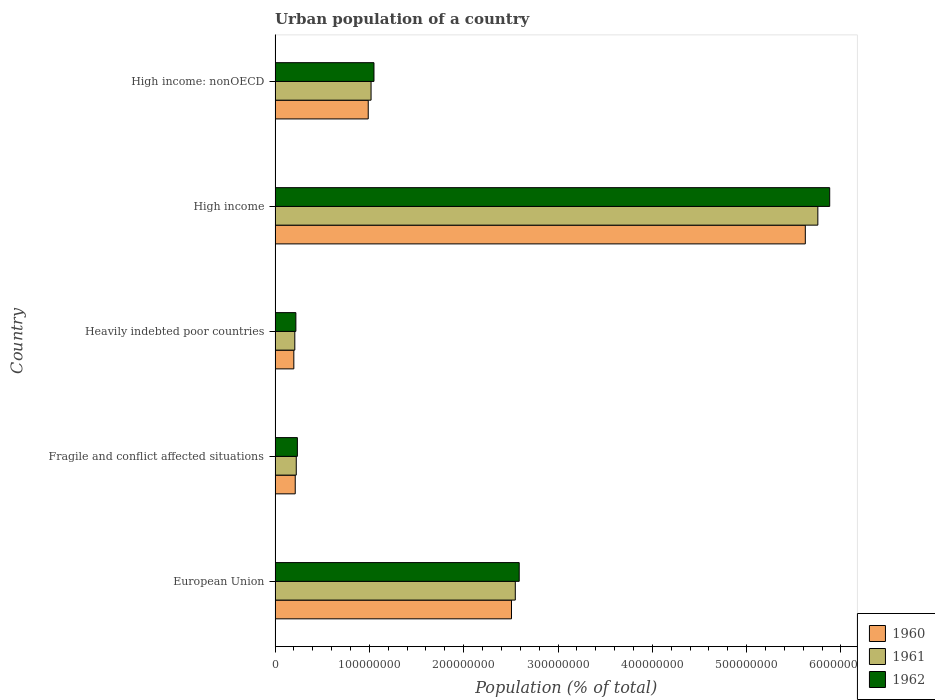How many different coloured bars are there?
Keep it short and to the point. 3. How many groups of bars are there?
Offer a very short reply. 5. How many bars are there on the 2nd tick from the bottom?
Keep it short and to the point. 3. What is the label of the 4th group of bars from the top?
Offer a very short reply. Fragile and conflict affected situations. What is the urban population in 1962 in Heavily indebted poor countries?
Ensure brevity in your answer.  2.20e+07. Across all countries, what is the maximum urban population in 1962?
Make the answer very short. 5.88e+08. Across all countries, what is the minimum urban population in 1960?
Keep it short and to the point. 1.99e+07. In which country was the urban population in 1960 minimum?
Provide a succinct answer. Heavily indebted poor countries. What is the total urban population in 1962 in the graph?
Give a very brief answer. 9.97e+08. What is the difference between the urban population in 1960 in European Union and that in Heavily indebted poor countries?
Your answer should be compact. 2.31e+08. What is the difference between the urban population in 1961 in High income and the urban population in 1962 in European Union?
Offer a very short reply. 3.17e+08. What is the average urban population in 1961 per country?
Your response must be concise. 1.95e+08. What is the difference between the urban population in 1962 and urban population in 1960 in High income: nonOECD?
Give a very brief answer. 6.07e+06. What is the ratio of the urban population in 1960 in High income to that in High income: nonOECD?
Give a very brief answer. 5.69. Is the urban population in 1961 in European Union less than that in Fragile and conflict affected situations?
Offer a terse response. No. What is the difference between the highest and the second highest urban population in 1960?
Provide a succinct answer. 3.12e+08. What is the difference between the highest and the lowest urban population in 1960?
Your answer should be compact. 5.42e+08. What does the 2nd bar from the top in Fragile and conflict affected situations represents?
Offer a very short reply. 1961. Are all the bars in the graph horizontal?
Ensure brevity in your answer.  Yes. Are the values on the major ticks of X-axis written in scientific E-notation?
Provide a succinct answer. No. Does the graph contain any zero values?
Offer a terse response. No. Does the graph contain grids?
Offer a terse response. No. How are the legend labels stacked?
Offer a very short reply. Vertical. What is the title of the graph?
Give a very brief answer. Urban population of a country. What is the label or title of the X-axis?
Your answer should be very brief. Population (% of total). What is the label or title of the Y-axis?
Make the answer very short. Country. What is the Population (% of total) of 1960 in European Union?
Keep it short and to the point. 2.51e+08. What is the Population (% of total) in 1961 in European Union?
Your response must be concise. 2.55e+08. What is the Population (% of total) of 1962 in European Union?
Give a very brief answer. 2.59e+08. What is the Population (% of total) of 1960 in Fragile and conflict affected situations?
Provide a short and direct response. 2.14e+07. What is the Population (% of total) of 1961 in Fragile and conflict affected situations?
Keep it short and to the point. 2.25e+07. What is the Population (% of total) of 1962 in Fragile and conflict affected situations?
Your answer should be compact. 2.36e+07. What is the Population (% of total) in 1960 in Heavily indebted poor countries?
Ensure brevity in your answer.  1.99e+07. What is the Population (% of total) of 1961 in Heavily indebted poor countries?
Offer a very short reply. 2.09e+07. What is the Population (% of total) of 1962 in Heavily indebted poor countries?
Ensure brevity in your answer.  2.20e+07. What is the Population (% of total) in 1960 in High income?
Provide a short and direct response. 5.62e+08. What is the Population (% of total) in 1961 in High income?
Ensure brevity in your answer.  5.76e+08. What is the Population (% of total) in 1962 in High income?
Offer a terse response. 5.88e+08. What is the Population (% of total) in 1960 in High income: nonOECD?
Provide a short and direct response. 9.88e+07. What is the Population (% of total) in 1961 in High income: nonOECD?
Keep it short and to the point. 1.02e+08. What is the Population (% of total) of 1962 in High income: nonOECD?
Offer a very short reply. 1.05e+08. Across all countries, what is the maximum Population (% of total) of 1960?
Your answer should be compact. 5.62e+08. Across all countries, what is the maximum Population (% of total) of 1961?
Ensure brevity in your answer.  5.76e+08. Across all countries, what is the maximum Population (% of total) in 1962?
Keep it short and to the point. 5.88e+08. Across all countries, what is the minimum Population (% of total) in 1960?
Keep it short and to the point. 1.99e+07. Across all countries, what is the minimum Population (% of total) of 1961?
Offer a terse response. 2.09e+07. Across all countries, what is the minimum Population (% of total) in 1962?
Make the answer very short. 2.20e+07. What is the total Population (% of total) of 1960 in the graph?
Make the answer very short. 9.53e+08. What is the total Population (% of total) in 1961 in the graph?
Offer a very short reply. 9.75e+08. What is the total Population (% of total) in 1962 in the graph?
Ensure brevity in your answer.  9.97e+08. What is the difference between the Population (% of total) in 1960 in European Union and that in Fragile and conflict affected situations?
Give a very brief answer. 2.29e+08. What is the difference between the Population (% of total) in 1961 in European Union and that in Fragile and conflict affected situations?
Give a very brief answer. 2.32e+08. What is the difference between the Population (% of total) of 1962 in European Union and that in Fragile and conflict affected situations?
Make the answer very short. 2.35e+08. What is the difference between the Population (% of total) of 1960 in European Union and that in Heavily indebted poor countries?
Your response must be concise. 2.31e+08. What is the difference between the Population (% of total) of 1961 in European Union and that in Heavily indebted poor countries?
Ensure brevity in your answer.  2.34e+08. What is the difference between the Population (% of total) in 1962 in European Union and that in Heavily indebted poor countries?
Provide a short and direct response. 2.37e+08. What is the difference between the Population (% of total) of 1960 in European Union and that in High income?
Provide a succinct answer. -3.12e+08. What is the difference between the Population (% of total) of 1961 in European Union and that in High income?
Keep it short and to the point. -3.21e+08. What is the difference between the Population (% of total) of 1962 in European Union and that in High income?
Give a very brief answer. -3.29e+08. What is the difference between the Population (% of total) in 1960 in European Union and that in High income: nonOECD?
Give a very brief answer. 1.52e+08. What is the difference between the Population (% of total) of 1961 in European Union and that in High income: nonOECD?
Keep it short and to the point. 1.53e+08. What is the difference between the Population (% of total) of 1962 in European Union and that in High income: nonOECD?
Ensure brevity in your answer.  1.54e+08. What is the difference between the Population (% of total) in 1960 in Fragile and conflict affected situations and that in Heavily indebted poor countries?
Ensure brevity in your answer.  1.48e+06. What is the difference between the Population (% of total) of 1961 in Fragile and conflict affected situations and that in Heavily indebted poor countries?
Make the answer very short. 1.53e+06. What is the difference between the Population (% of total) of 1962 in Fragile and conflict affected situations and that in Heavily indebted poor countries?
Keep it short and to the point. 1.59e+06. What is the difference between the Population (% of total) of 1960 in Fragile and conflict affected situations and that in High income?
Make the answer very short. -5.41e+08. What is the difference between the Population (% of total) of 1961 in Fragile and conflict affected situations and that in High income?
Offer a very short reply. -5.53e+08. What is the difference between the Population (% of total) in 1962 in Fragile and conflict affected situations and that in High income?
Provide a short and direct response. -5.64e+08. What is the difference between the Population (% of total) of 1960 in Fragile and conflict affected situations and that in High income: nonOECD?
Provide a succinct answer. -7.74e+07. What is the difference between the Population (% of total) in 1961 in Fragile and conflict affected situations and that in High income: nonOECD?
Keep it short and to the point. -7.93e+07. What is the difference between the Population (% of total) in 1962 in Fragile and conflict affected situations and that in High income: nonOECD?
Ensure brevity in your answer.  -8.12e+07. What is the difference between the Population (% of total) in 1960 in Heavily indebted poor countries and that in High income?
Your response must be concise. -5.42e+08. What is the difference between the Population (% of total) of 1961 in Heavily indebted poor countries and that in High income?
Make the answer very short. -5.55e+08. What is the difference between the Population (% of total) in 1962 in Heavily indebted poor countries and that in High income?
Offer a terse response. -5.66e+08. What is the difference between the Population (% of total) in 1960 in Heavily indebted poor countries and that in High income: nonOECD?
Make the answer very short. -7.89e+07. What is the difference between the Population (% of total) in 1961 in Heavily indebted poor countries and that in High income: nonOECD?
Provide a short and direct response. -8.08e+07. What is the difference between the Population (% of total) of 1962 in Heavily indebted poor countries and that in High income: nonOECD?
Your answer should be compact. -8.28e+07. What is the difference between the Population (% of total) in 1960 in High income and that in High income: nonOECD?
Offer a terse response. 4.63e+08. What is the difference between the Population (% of total) in 1961 in High income and that in High income: nonOECD?
Make the answer very short. 4.74e+08. What is the difference between the Population (% of total) in 1962 in High income and that in High income: nonOECD?
Your answer should be very brief. 4.83e+08. What is the difference between the Population (% of total) of 1960 in European Union and the Population (% of total) of 1961 in Fragile and conflict affected situations?
Make the answer very short. 2.28e+08. What is the difference between the Population (% of total) in 1960 in European Union and the Population (% of total) in 1962 in Fragile and conflict affected situations?
Your answer should be very brief. 2.27e+08. What is the difference between the Population (% of total) in 1961 in European Union and the Population (% of total) in 1962 in Fragile and conflict affected situations?
Offer a very short reply. 2.31e+08. What is the difference between the Population (% of total) of 1960 in European Union and the Population (% of total) of 1961 in Heavily indebted poor countries?
Provide a short and direct response. 2.30e+08. What is the difference between the Population (% of total) in 1960 in European Union and the Population (% of total) in 1962 in Heavily indebted poor countries?
Your answer should be compact. 2.29e+08. What is the difference between the Population (% of total) in 1961 in European Union and the Population (% of total) in 1962 in Heavily indebted poor countries?
Give a very brief answer. 2.33e+08. What is the difference between the Population (% of total) of 1960 in European Union and the Population (% of total) of 1961 in High income?
Your response must be concise. -3.25e+08. What is the difference between the Population (% of total) of 1960 in European Union and the Population (% of total) of 1962 in High income?
Your answer should be very brief. -3.37e+08. What is the difference between the Population (% of total) in 1961 in European Union and the Population (% of total) in 1962 in High income?
Your response must be concise. -3.33e+08. What is the difference between the Population (% of total) of 1960 in European Union and the Population (% of total) of 1961 in High income: nonOECD?
Offer a terse response. 1.49e+08. What is the difference between the Population (% of total) of 1960 in European Union and the Population (% of total) of 1962 in High income: nonOECD?
Your answer should be very brief. 1.46e+08. What is the difference between the Population (% of total) in 1961 in European Union and the Population (% of total) in 1962 in High income: nonOECD?
Your response must be concise. 1.50e+08. What is the difference between the Population (% of total) in 1960 in Fragile and conflict affected situations and the Population (% of total) in 1961 in Heavily indebted poor countries?
Make the answer very short. 4.34e+05. What is the difference between the Population (% of total) in 1960 in Fragile and conflict affected situations and the Population (% of total) in 1962 in Heavily indebted poor countries?
Make the answer very short. -6.80e+05. What is the difference between the Population (% of total) in 1961 in Fragile and conflict affected situations and the Population (% of total) in 1962 in Heavily indebted poor countries?
Give a very brief answer. 4.21e+05. What is the difference between the Population (% of total) in 1960 in Fragile and conflict affected situations and the Population (% of total) in 1961 in High income?
Your answer should be very brief. -5.54e+08. What is the difference between the Population (% of total) in 1960 in Fragile and conflict affected situations and the Population (% of total) in 1962 in High income?
Provide a short and direct response. -5.67e+08. What is the difference between the Population (% of total) of 1961 in Fragile and conflict affected situations and the Population (% of total) of 1962 in High income?
Offer a very short reply. -5.66e+08. What is the difference between the Population (% of total) of 1960 in Fragile and conflict affected situations and the Population (% of total) of 1961 in High income: nonOECD?
Your answer should be very brief. -8.04e+07. What is the difference between the Population (% of total) of 1960 in Fragile and conflict affected situations and the Population (% of total) of 1962 in High income: nonOECD?
Make the answer very short. -8.35e+07. What is the difference between the Population (% of total) in 1961 in Fragile and conflict affected situations and the Population (% of total) in 1962 in High income: nonOECD?
Give a very brief answer. -8.24e+07. What is the difference between the Population (% of total) in 1960 in Heavily indebted poor countries and the Population (% of total) in 1961 in High income?
Offer a very short reply. -5.56e+08. What is the difference between the Population (% of total) of 1960 in Heavily indebted poor countries and the Population (% of total) of 1962 in High income?
Keep it short and to the point. -5.68e+08. What is the difference between the Population (% of total) in 1961 in Heavily indebted poor countries and the Population (% of total) in 1962 in High income?
Give a very brief answer. -5.67e+08. What is the difference between the Population (% of total) in 1960 in Heavily indebted poor countries and the Population (% of total) in 1961 in High income: nonOECD?
Keep it short and to the point. -8.19e+07. What is the difference between the Population (% of total) in 1960 in Heavily indebted poor countries and the Population (% of total) in 1962 in High income: nonOECD?
Provide a succinct answer. -8.50e+07. What is the difference between the Population (% of total) of 1961 in Heavily indebted poor countries and the Population (% of total) of 1962 in High income: nonOECD?
Ensure brevity in your answer.  -8.39e+07. What is the difference between the Population (% of total) in 1960 in High income and the Population (% of total) in 1961 in High income: nonOECD?
Offer a very short reply. 4.60e+08. What is the difference between the Population (% of total) in 1960 in High income and the Population (% of total) in 1962 in High income: nonOECD?
Offer a very short reply. 4.57e+08. What is the difference between the Population (% of total) of 1961 in High income and the Population (% of total) of 1962 in High income: nonOECD?
Your answer should be very brief. 4.71e+08. What is the average Population (% of total) of 1960 per country?
Your answer should be very brief. 1.91e+08. What is the average Population (% of total) of 1961 per country?
Your answer should be compact. 1.95e+08. What is the average Population (% of total) in 1962 per country?
Keep it short and to the point. 1.99e+08. What is the difference between the Population (% of total) of 1960 and Population (% of total) of 1961 in European Union?
Make the answer very short. -4.05e+06. What is the difference between the Population (% of total) of 1960 and Population (% of total) of 1962 in European Union?
Offer a very short reply. -8.20e+06. What is the difference between the Population (% of total) in 1961 and Population (% of total) in 1962 in European Union?
Your answer should be compact. -4.14e+06. What is the difference between the Population (% of total) in 1960 and Population (% of total) in 1961 in Fragile and conflict affected situations?
Provide a succinct answer. -1.10e+06. What is the difference between the Population (% of total) of 1960 and Population (% of total) of 1962 in Fragile and conflict affected situations?
Your answer should be very brief. -2.27e+06. What is the difference between the Population (% of total) of 1961 and Population (% of total) of 1962 in Fragile and conflict affected situations?
Provide a short and direct response. -1.17e+06. What is the difference between the Population (% of total) in 1960 and Population (% of total) in 1961 in Heavily indebted poor countries?
Keep it short and to the point. -1.05e+06. What is the difference between the Population (% of total) in 1960 and Population (% of total) in 1962 in Heavily indebted poor countries?
Make the answer very short. -2.16e+06. What is the difference between the Population (% of total) of 1961 and Population (% of total) of 1962 in Heavily indebted poor countries?
Provide a short and direct response. -1.11e+06. What is the difference between the Population (% of total) of 1960 and Population (% of total) of 1961 in High income?
Provide a succinct answer. -1.33e+07. What is the difference between the Population (% of total) in 1960 and Population (% of total) in 1962 in High income?
Offer a very short reply. -2.59e+07. What is the difference between the Population (% of total) of 1961 and Population (% of total) of 1962 in High income?
Ensure brevity in your answer.  -1.26e+07. What is the difference between the Population (% of total) in 1960 and Population (% of total) in 1961 in High income: nonOECD?
Your answer should be compact. -2.99e+06. What is the difference between the Population (% of total) in 1960 and Population (% of total) in 1962 in High income: nonOECD?
Provide a succinct answer. -6.07e+06. What is the difference between the Population (% of total) in 1961 and Population (% of total) in 1962 in High income: nonOECD?
Provide a succinct answer. -3.08e+06. What is the ratio of the Population (% of total) of 1960 in European Union to that in Fragile and conflict affected situations?
Give a very brief answer. 11.73. What is the ratio of the Population (% of total) in 1961 in European Union to that in Fragile and conflict affected situations?
Give a very brief answer. 11.34. What is the ratio of the Population (% of total) of 1962 in European Union to that in Fragile and conflict affected situations?
Provide a short and direct response. 10.95. What is the ratio of the Population (% of total) in 1960 in European Union to that in Heavily indebted poor countries?
Your answer should be very brief. 12.61. What is the ratio of the Population (% of total) of 1961 in European Union to that in Heavily indebted poor countries?
Ensure brevity in your answer.  12.17. What is the ratio of the Population (% of total) in 1962 in European Union to that in Heavily indebted poor countries?
Provide a succinct answer. 11.74. What is the ratio of the Population (% of total) of 1960 in European Union to that in High income?
Provide a succinct answer. 0.45. What is the ratio of the Population (% of total) in 1961 in European Union to that in High income?
Keep it short and to the point. 0.44. What is the ratio of the Population (% of total) of 1962 in European Union to that in High income?
Ensure brevity in your answer.  0.44. What is the ratio of the Population (% of total) in 1960 in European Union to that in High income: nonOECD?
Offer a very short reply. 2.54. What is the ratio of the Population (% of total) in 1961 in European Union to that in High income: nonOECD?
Make the answer very short. 2.5. What is the ratio of the Population (% of total) in 1962 in European Union to that in High income: nonOECD?
Provide a short and direct response. 2.47. What is the ratio of the Population (% of total) of 1960 in Fragile and conflict affected situations to that in Heavily indebted poor countries?
Make the answer very short. 1.07. What is the ratio of the Population (% of total) of 1961 in Fragile and conflict affected situations to that in Heavily indebted poor countries?
Offer a terse response. 1.07. What is the ratio of the Population (% of total) in 1962 in Fragile and conflict affected situations to that in Heavily indebted poor countries?
Offer a terse response. 1.07. What is the ratio of the Population (% of total) of 1960 in Fragile and conflict affected situations to that in High income?
Your answer should be compact. 0.04. What is the ratio of the Population (% of total) in 1961 in Fragile and conflict affected situations to that in High income?
Give a very brief answer. 0.04. What is the ratio of the Population (% of total) in 1962 in Fragile and conflict affected situations to that in High income?
Give a very brief answer. 0.04. What is the ratio of the Population (% of total) in 1960 in Fragile and conflict affected situations to that in High income: nonOECD?
Offer a very short reply. 0.22. What is the ratio of the Population (% of total) in 1961 in Fragile and conflict affected situations to that in High income: nonOECD?
Your response must be concise. 0.22. What is the ratio of the Population (% of total) in 1962 in Fragile and conflict affected situations to that in High income: nonOECD?
Make the answer very short. 0.23. What is the ratio of the Population (% of total) of 1960 in Heavily indebted poor countries to that in High income?
Ensure brevity in your answer.  0.04. What is the ratio of the Population (% of total) of 1961 in Heavily indebted poor countries to that in High income?
Your answer should be compact. 0.04. What is the ratio of the Population (% of total) of 1962 in Heavily indebted poor countries to that in High income?
Provide a succinct answer. 0.04. What is the ratio of the Population (% of total) of 1960 in Heavily indebted poor countries to that in High income: nonOECD?
Your answer should be very brief. 0.2. What is the ratio of the Population (% of total) in 1961 in Heavily indebted poor countries to that in High income: nonOECD?
Offer a terse response. 0.21. What is the ratio of the Population (% of total) of 1962 in Heavily indebted poor countries to that in High income: nonOECD?
Make the answer very short. 0.21. What is the ratio of the Population (% of total) of 1960 in High income to that in High income: nonOECD?
Offer a very short reply. 5.69. What is the ratio of the Population (% of total) of 1961 in High income to that in High income: nonOECD?
Your response must be concise. 5.65. What is the ratio of the Population (% of total) in 1962 in High income to that in High income: nonOECD?
Offer a terse response. 5.61. What is the difference between the highest and the second highest Population (% of total) in 1960?
Your response must be concise. 3.12e+08. What is the difference between the highest and the second highest Population (% of total) of 1961?
Offer a terse response. 3.21e+08. What is the difference between the highest and the second highest Population (% of total) in 1962?
Offer a very short reply. 3.29e+08. What is the difference between the highest and the lowest Population (% of total) of 1960?
Provide a short and direct response. 5.42e+08. What is the difference between the highest and the lowest Population (% of total) of 1961?
Your answer should be compact. 5.55e+08. What is the difference between the highest and the lowest Population (% of total) of 1962?
Provide a succinct answer. 5.66e+08. 